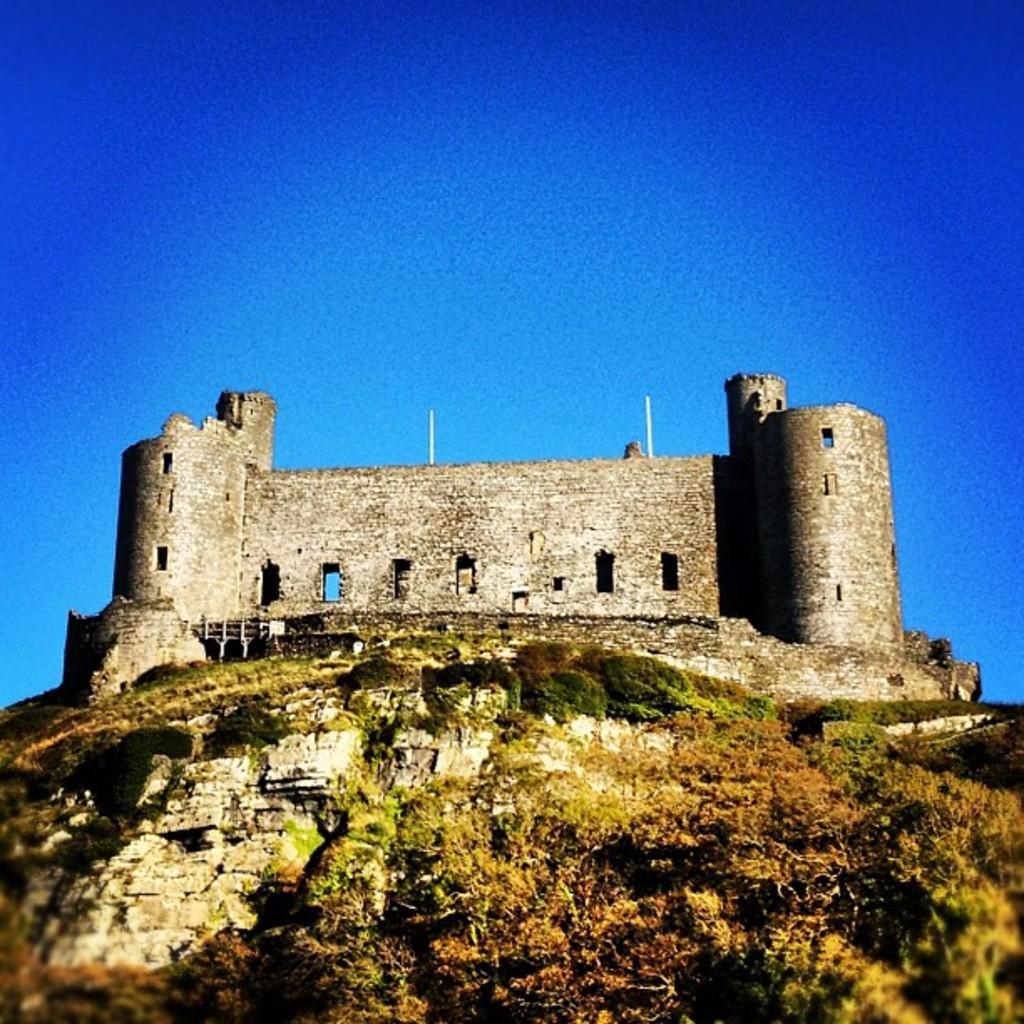Could you give a brief overview of what you see in this image? This picture shows a monument and we see trees and a blue sky 